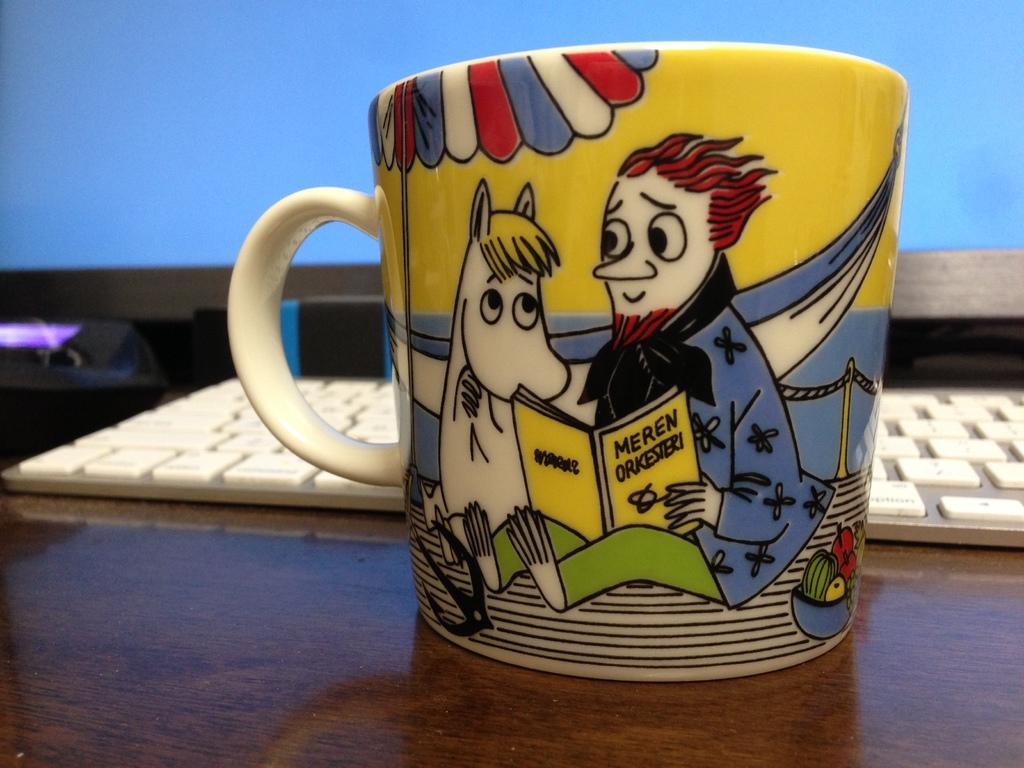<image>
Share a concise interpretation of the image provided. Cup showing a man reading to a horse with the book "Meren Orkesieri". 